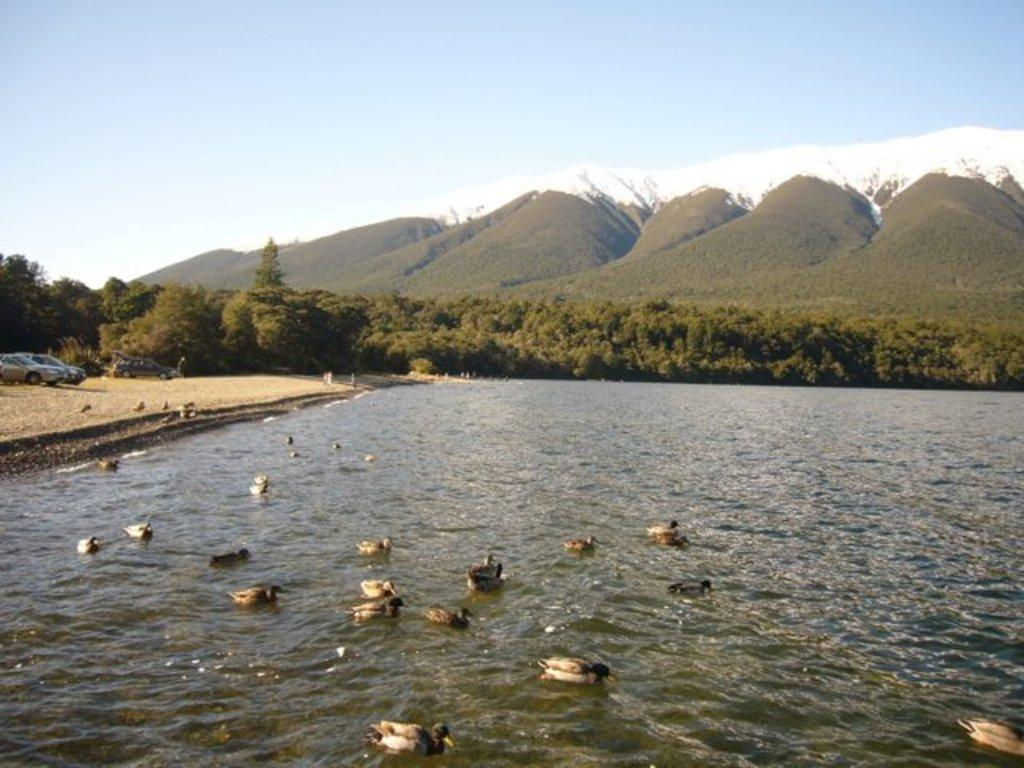What type of animals can be seen in the water in the image? There are birds in the water in the image. What is visible on the ground in the image? The ground is visible in the image. What types of transportation can be seen in the image? There are vehicles in the image. What type of vegetation is present in the image? There are trees in the image. What type of geographical feature can be seen in the image? There are hills in the image in the image. What is visible in the sky in the image? The sky is visible in the image, and clouds are present. What type of church can be seen in the image? There is no church present in the image. What type of beam is holding up the trees in the image? There are no beams holding up the trees in the image; the trees are standing on their own. 